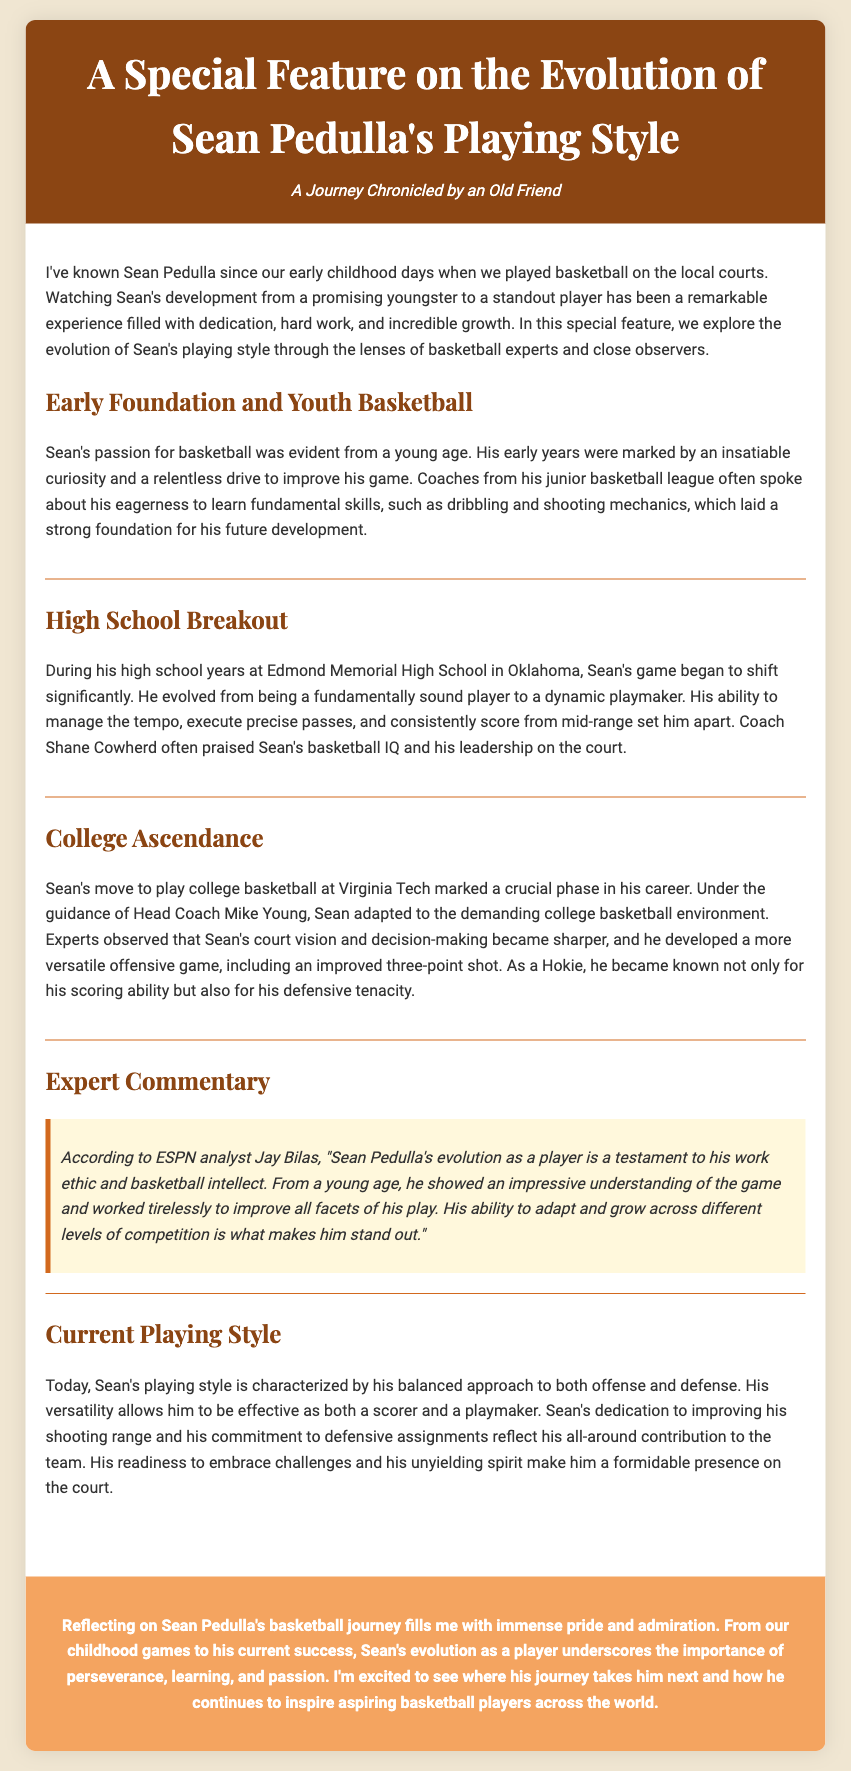What is the title of the feature? The title of the feature is mentioned at the top of the document, emphasizing the focus on Sean's playing style evolution.
Answer: A Special Feature on the Evolution of Sean Pedulla's Playing Style Who coached Sean at Edmond Memorial High School? The document explicitly names Coach Shane Cowherd as Sean's high school coach, who praised his talents.
Answer: Shane Cowherd What is one aspect of Sean's game that improved during college? The document highlights that during college, Sean developed a more versatile offensive game, which included a specific skill.
Answer: Improved three-point shot Which analyst commented on Sean's evolution? The document includes a quote from a specific basketball analyst who commented on Sean's development and work ethic.
Answer: Jay Bilas What emotion does the author express about Sean's journey? The conclusion reflects on the author's feelings regarding Sean's evolution as a player, emphasizing a particular sentiment.
Answer: Pride 